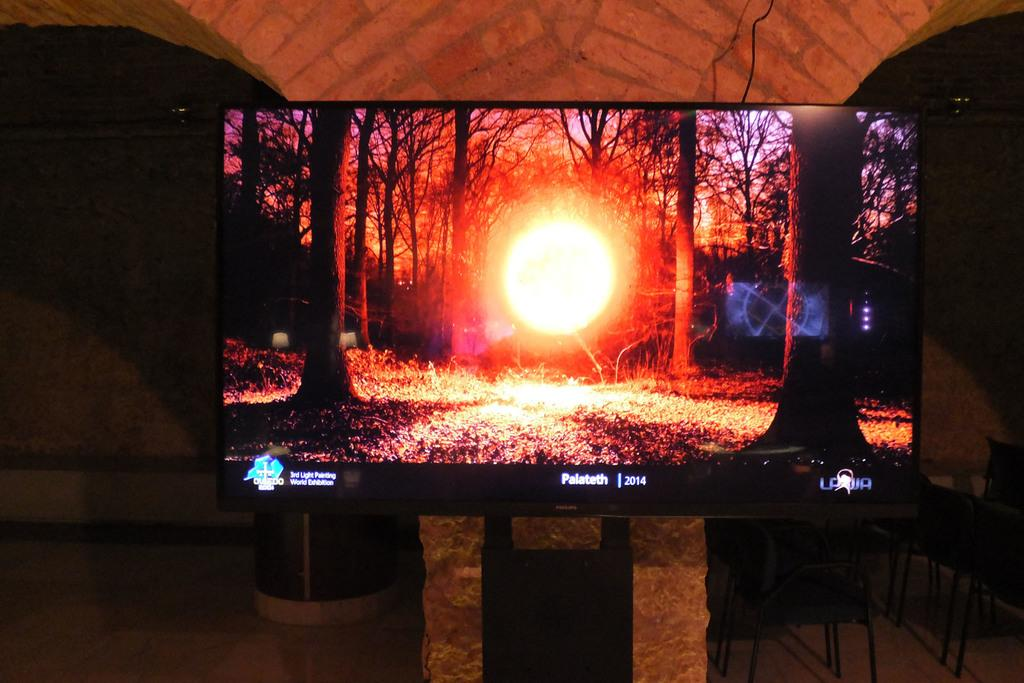<image>
Provide a brief description of the given image. A Phillips TV is showing an image of the sun through the trees and Palateth 2014 at the bottom. 